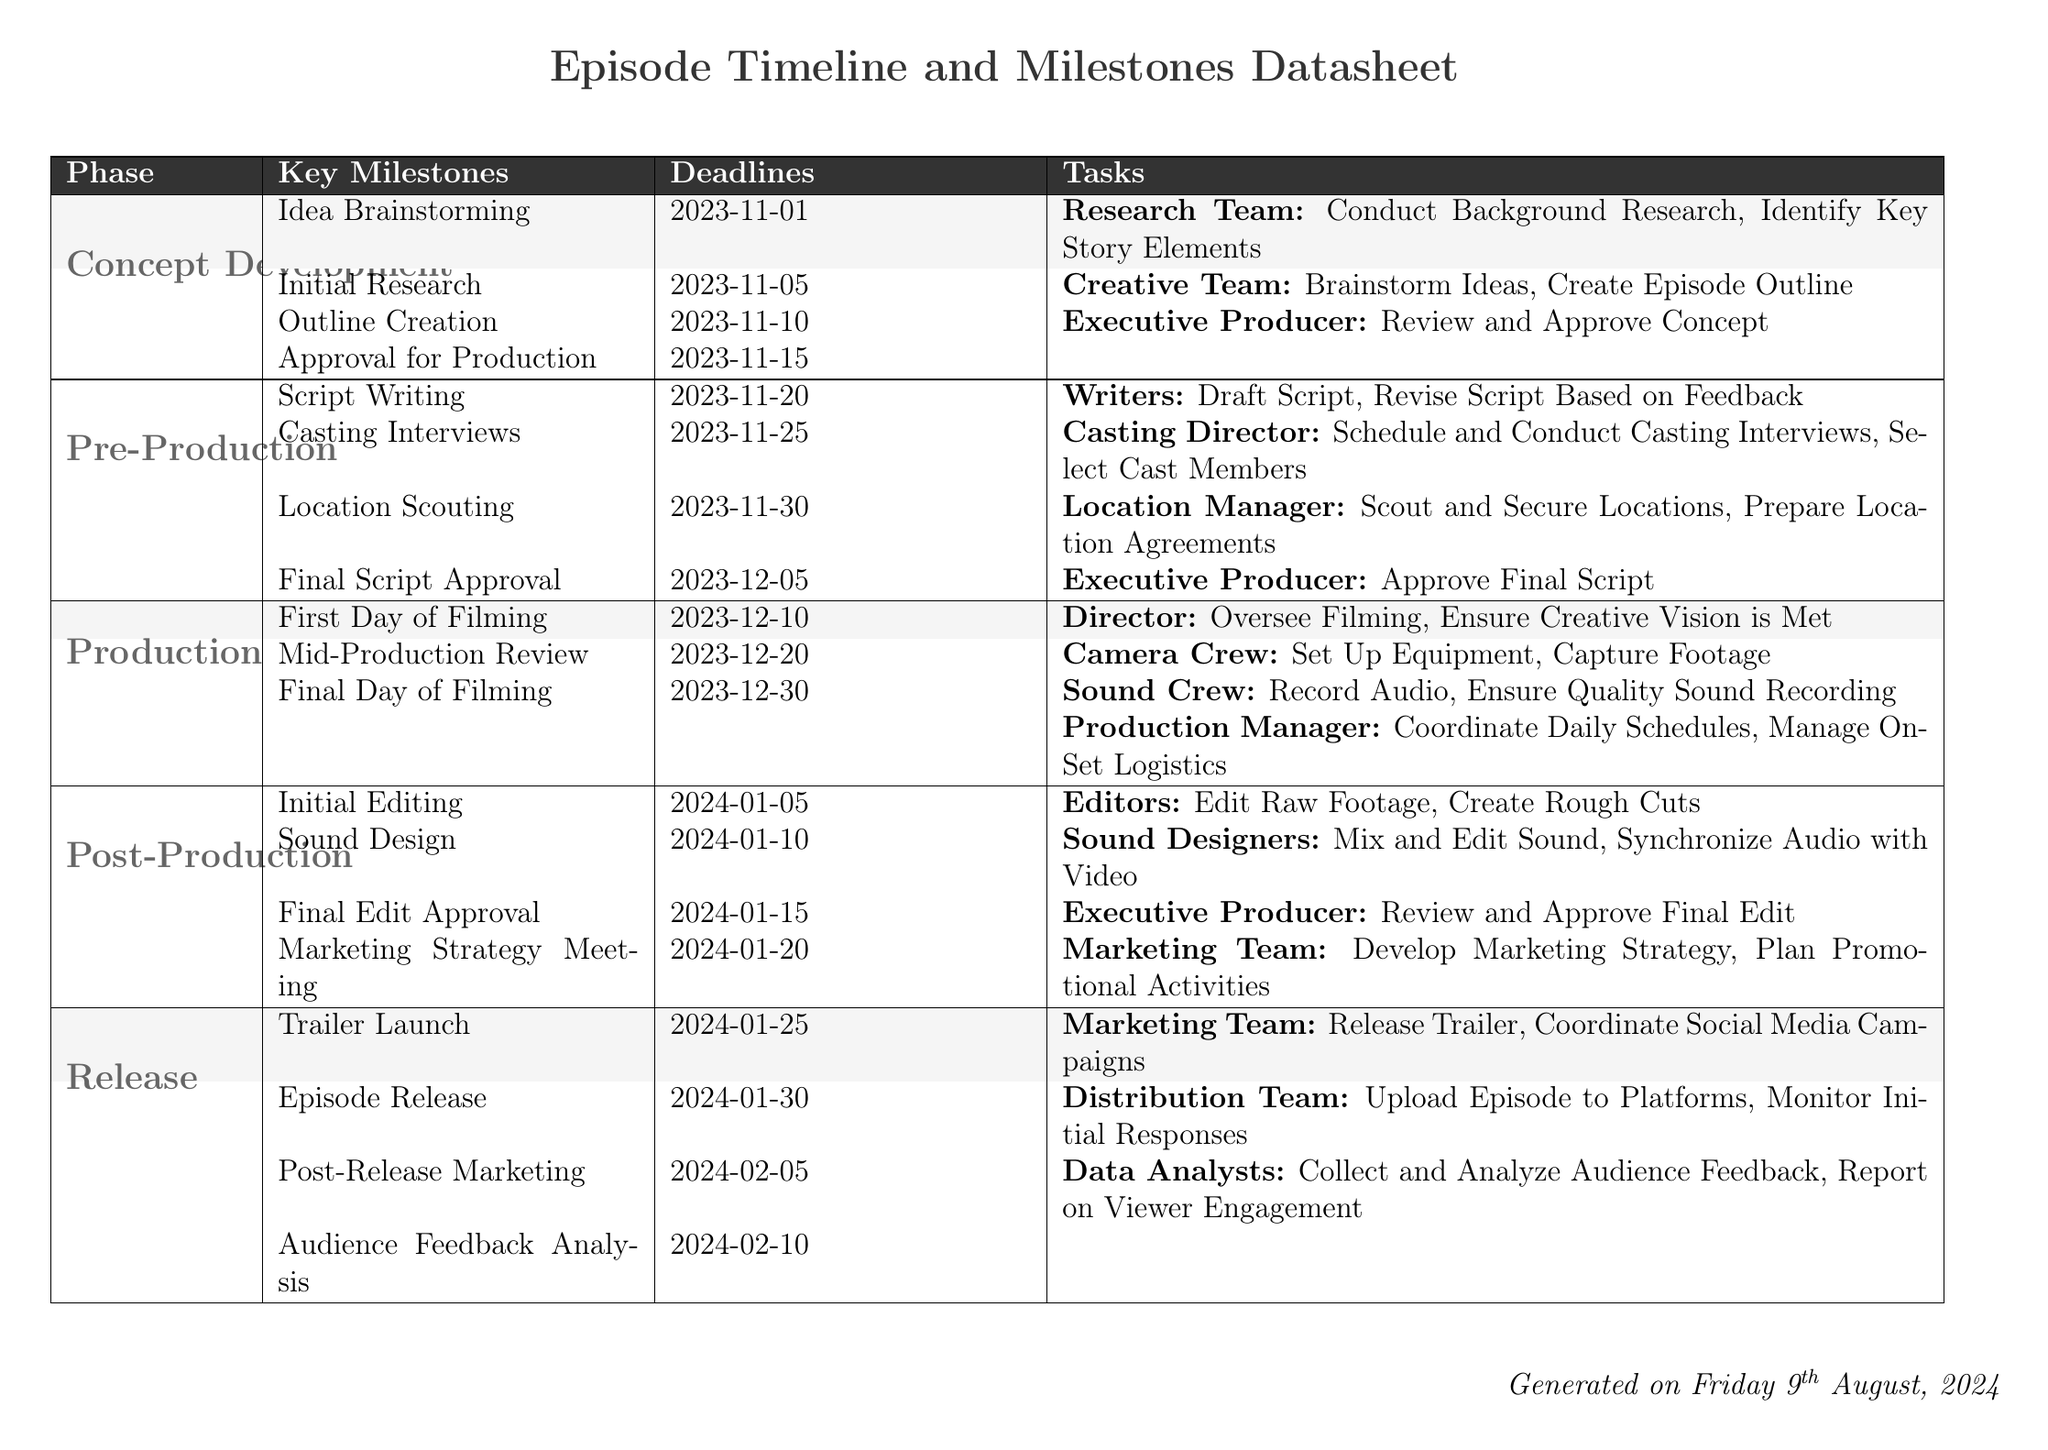what is the first milestone in Concept Development? The first milestone in Concept Development is Idea Brainstorming on 2023-11-01.
Answer: Idea Brainstorming what is the deadline for Final Script Approval? The deadline for Final Script Approval is on 2023-12-05.
Answer: 2023-12-05 who is responsible for sound design tasks? The Sound Designers are responsible for sound design tasks.
Answer: Sound Designers how many tasks are listed under the Production phase? There are three tasks listed under the Production phase.
Answer: 3 what is the date of the Episode Release? The date of the Episode Release is on 2024-01-30.
Answer: 2024-01-30 what is the last milestone listed in the Release phase? The last milestone listed in the Release phase is Audience Feedback Analysis.
Answer: Audience Feedback Analysis who approves the final edit? The Executive Producer approves the final edit.
Answer: Executive Producer what is the second task listed under Post-Production? The second task listed under Post-Production is to mix and edit sound.
Answer: Mix and Edit Sound 